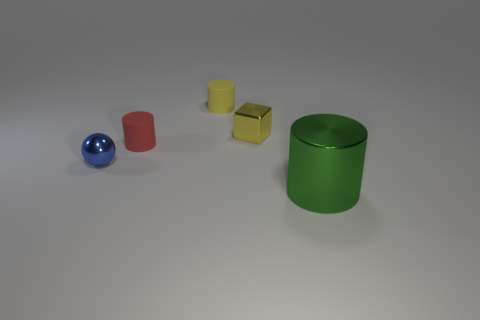Add 5 yellow shiny objects. How many objects exist? 10 Subtract all blocks. How many objects are left? 4 Add 5 yellow cylinders. How many yellow cylinders exist? 6 Subtract 0 red blocks. How many objects are left? 5 Subtract all big green shiny cylinders. Subtract all tiny brown shiny cubes. How many objects are left? 4 Add 5 cylinders. How many cylinders are left? 8 